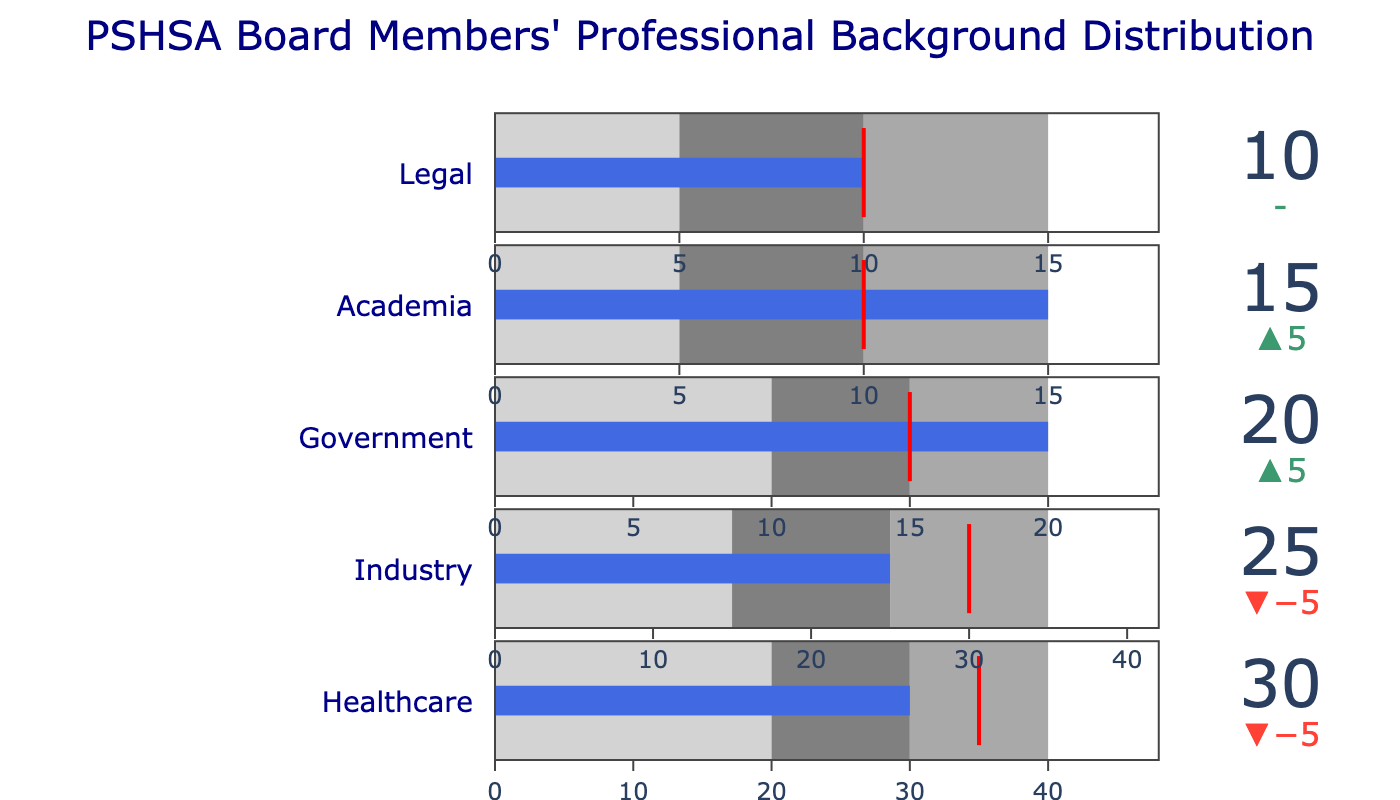What is the title of the chart? The title is usually located at the top of the chart and provides a brief summary of what the chart represents. In this case, it specifies the type and subject of the data—PSHSA Board Members' Professional Background Distribution.
Answer: PSHSA Board Members' Professional Background Distribution What are the categories represented in the chart? The categories are listed vertically along the chart and indicate the different professional backgrounds of PSHSA Board members. These categories are Healthcare, Industry, Government, Academia, and Legal.
Answer: Healthcare, Industry, Government, Academia, Legal What is the target value for the Healthcare category? The target value is marked by a threshold line or indicator in the bullet chart for each category. In the Healthcare category, the target value is explicitly given as 35.
Answer: 35 What's the sum of actual values across all categories? The sum is calculated by adding all actual values together: 30 (Healthcare) + 25 (Industry) + 20 (Government) + 15 (Academia) + 10 (Legal) = 100.
Answer: 100 Is the number of board members from the Government category higher or lower than the target? We compare the actual value (20) to the target value (15) for the Government category. Since 20 is greater than 15, the number is higher.
Answer: Higher Which category meets its target value? A category meets its target value when the actual value equals the target. In this case, the only category with the actual value equal to the target value is Legal (10 == 10).
Answer: Legal In which ranges does the Healthcare category fall? The range breakdowns are indicated by the shaded bars in the bullet chart. For Healthcare: 30 is within Range 2 (20-30).
Answer: Range 2 (20-30) Which category falls below its target but within its acceptable range? We look for categories where the actual value is below the target but within Range 3. Healthcare (30 < 35 but within 20-40), Industry (25 < 30 but within 15-35) are clear options. Government (20 > 15), Academia (15 > 10), and Legal (10 == 10) do not meet both criteria. So, both Healthcare and Industry qualify here.
Answer: Healthcare, Industry What is the difference between the actual and target values for Academia? The difference is found by subtracting the target value from the actual value: 15 - 10 = 5.
Answer: 5 